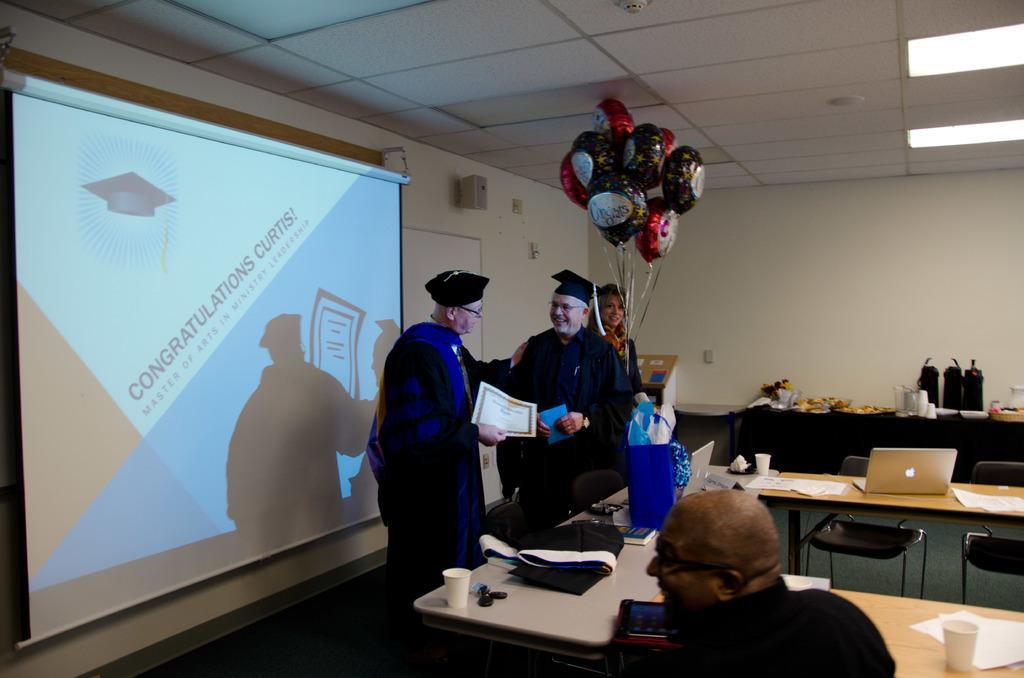Please provide a concise description of this image. In this there are two men with black dress standing and behind him there is a lady holding balloons in her hand. And to the bottom another man with black dress is sitting and he is smiling. In front of him there is a table with glass, paper, laptop, blue color cover and books on it. In to the left side there is a screen. 